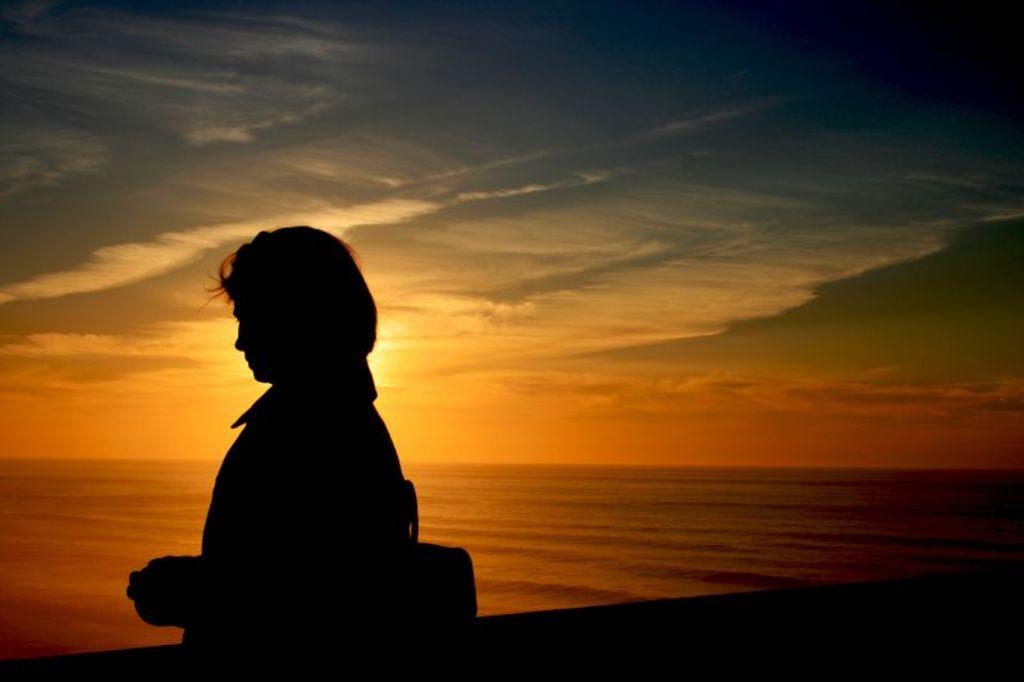Who or what is present in the image? There is a person in the image. What is the primary element visible in the image? Water is visible in the image. What can be seen in the background of the image? The sky is visible in the background of the image. What is the range of the person's fictional abilities in the image? The image does not depict any fictional abilities or characters, so it is not possible to determine the range of the person's fictional abilities. 